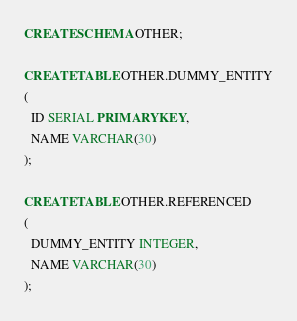<code> <loc_0><loc_0><loc_500><loc_500><_SQL_>CREATE SCHEMA OTHER;

CREATE TABLE OTHER.DUMMY_ENTITY
(
  ID SERIAL PRIMARY KEY,
  NAME VARCHAR(30)
);

CREATE TABLE OTHER.REFERENCED
(
  DUMMY_ENTITY INTEGER,
  NAME VARCHAR(30)
);

</code> 